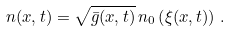<formula> <loc_0><loc_0><loc_500><loc_500>n ( x , t ) = \sqrt { \bar { g } ( x , t ) } \, n _ { 0 } \left ( \xi ( x , t ) \right ) \, .</formula> 